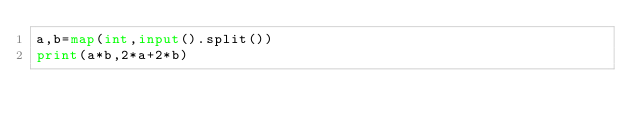<code> <loc_0><loc_0><loc_500><loc_500><_Python_>a,b=map(int,input().split())
print(a*b,2*a+2*b)
</code> 